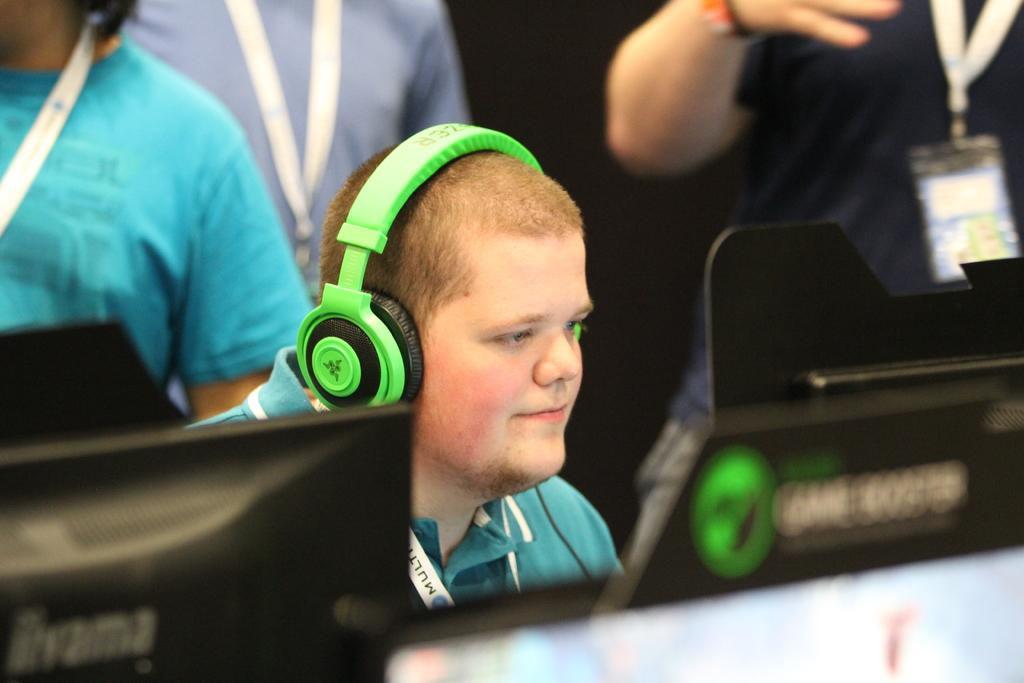How many people are in the image? There are people in the image, but the exact number is not specified. Can you describe any specific person in the image? Yes, there is a person with a headset in the image. What can be seen at the bottom of the image? There are objects at the bottom of the image. What suggestion does the person with the headset make in the image? There is no information about any suggestions being made in the image. Can you describe the stomach of the person with the headset in the image? The image does not show the person's stomach, so it cannot be described. 